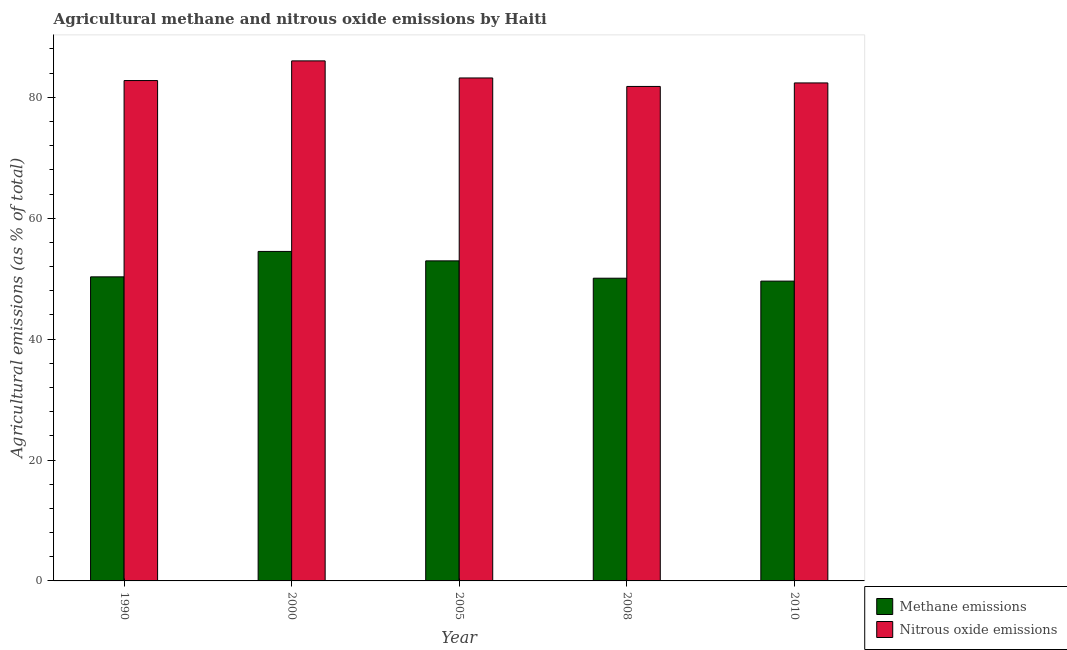Are the number of bars per tick equal to the number of legend labels?
Offer a very short reply. Yes. How many bars are there on the 5th tick from the right?
Make the answer very short. 2. What is the label of the 1st group of bars from the left?
Give a very brief answer. 1990. In how many cases, is the number of bars for a given year not equal to the number of legend labels?
Your answer should be very brief. 0. What is the amount of methane emissions in 2005?
Ensure brevity in your answer.  52.94. Across all years, what is the maximum amount of nitrous oxide emissions?
Provide a short and direct response. 86.03. Across all years, what is the minimum amount of nitrous oxide emissions?
Provide a short and direct response. 81.8. What is the total amount of nitrous oxide emissions in the graph?
Your response must be concise. 416.19. What is the difference between the amount of methane emissions in 2000 and that in 2008?
Make the answer very short. 4.43. What is the difference between the amount of methane emissions in 2005 and the amount of nitrous oxide emissions in 2008?
Your response must be concise. 2.87. What is the average amount of methane emissions per year?
Make the answer very short. 51.49. What is the ratio of the amount of methane emissions in 2008 to that in 2010?
Keep it short and to the point. 1.01. Is the amount of nitrous oxide emissions in 2000 less than that in 2008?
Keep it short and to the point. No. Is the difference between the amount of methane emissions in 1990 and 2000 greater than the difference between the amount of nitrous oxide emissions in 1990 and 2000?
Make the answer very short. No. What is the difference between the highest and the second highest amount of methane emissions?
Your response must be concise. 1.56. What is the difference between the highest and the lowest amount of nitrous oxide emissions?
Make the answer very short. 4.23. In how many years, is the amount of methane emissions greater than the average amount of methane emissions taken over all years?
Your answer should be compact. 2. What does the 1st bar from the left in 1990 represents?
Provide a short and direct response. Methane emissions. What does the 2nd bar from the right in 2005 represents?
Your answer should be compact. Methane emissions. How many years are there in the graph?
Offer a terse response. 5. Are the values on the major ticks of Y-axis written in scientific E-notation?
Your answer should be very brief. No. How many legend labels are there?
Ensure brevity in your answer.  2. What is the title of the graph?
Ensure brevity in your answer.  Agricultural methane and nitrous oxide emissions by Haiti. What is the label or title of the Y-axis?
Your answer should be very brief. Agricultural emissions (as % of total). What is the Agricultural emissions (as % of total) in Methane emissions in 1990?
Your answer should be very brief. 50.3. What is the Agricultural emissions (as % of total) of Nitrous oxide emissions in 1990?
Provide a short and direct response. 82.77. What is the Agricultural emissions (as % of total) of Methane emissions in 2000?
Your answer should be very brief. 54.51. What is the Agricultural emissions (as % of total) in Nitrous oxide emissions in 2000?
Give a very brief answer. 86.03. What is the Agricultural emissions (as % of total) in Methane emissions in 2005?
Make the answer very short. 52.94. What is the Agricultural emissions (as % of total) of Nitrous oxide emissions in 2005?
Your response must be concise. 83.2. What is the Agricultural emissions (as % of total) of Methane emissions in 2008?
Provide a succinct answer. 50.08. What is the Agricultural emissions (as % of total) in Nitrous oxide emissions in 2008?
Provide a succinct answer. 81.8. What is the Agricultural emissions (as % of total) of Methane emissions in 2010?
Offer a terse response. 49.6. What is the Agricultural emissions (as % of total) in Nitrous oxide emissions in 2010?
Keep it short and to the point. 82.38. Across all years, what is the maximum Agricultural emissions (as % of total) in Methane emissions?
Your response must be concise. 54.51. Across all years, what is the maximum Agricultural emissions (as % of total) of Nitrous oxide emissions?
Keep it short and to the point. 86.03. Across all years, what is the minimum Agricultural emissions (as % of total) in Methane emissions?
Give a very brief answer. 49.6. Across all years, what is the minimum Agricultural emissions (as % of total) of Nitrous oxide emissions?
Your answer should be compact. 81.8. What is the total Agricultural emissions (as % of total) of Methane emissions in the graph?
Ensure brevity in your answer.  257.43. What is the total Agricultural emissions (as % of total) of Nitrous oxide emissions in the graph?
Provide a succinct answer. 416.19. What is the difference between the Agricultural emissions (as % of total) in Methane emissions in 1990 and that in 2000?
Your answer should be compact. -4.2. What is the difference between the Agricultural emissions (as % of total) in Nitrous oxide emissions in 1990 and that in 2000?
Provide a short and direct response. -3.25. What is the difference between the Agricultural emissions (as % of total) in Methane emissions in 1990 and that in 2005?
Offer a very short reply. -2.64. What is the difference between the Agricultural emissions (as % of total) of Nitrous oxide emissions in 1990 and that in 2005?
Provide a succinct answer. -0.43. What is the difference between the Agricultural emissions (as % of total) in Methane emissions in 1990 and that in 2008?
Provide a succinct answer. 0.23. What is the difference between the Agricultural emissions (as % of total) in Nitrous oxide emissions in 1990 and that in 2008?
Provide a succinct answer. 0.97. What is the difference between the Agricultural emissions (as % of total) of Methane emissions in 1990 and that in 2010?
Provide a short and direct response. 0.71. What is the difference between the Agricultural emissions (as % of total) of Nitrous oxide emissions in 1990 and that in 2010?
Keep it short and to the point. 0.39. What is the difference between the Agricultural emissions (as % of total) in Methane emissions in 2000 and that in 2005?
Offer a very short reply. 1.56. What is the difference between the Agricultural emissions (as % of total) in Nitrous oxide emissions in 2000 and that in 2005?
Ensure brevity in your answer.  2.83. What is the difference between the Agricultural emissions (as % of total) in Methane emissions in 2000 and that in 2008?
Provide a succinct answer. 4.43. What is the difference between the Agricultural emissions (as % of total) of Nitrous oxide emissions in 2000 and that in 2008?
Offer a very short reply. 4.23. What is the difference between the Agricultural emissions (as % of total) in Methane emissions in 2000 and that in 2010?
Provide a succinct answer. 4.91. What is the difference between the Agricultural emissions (as % of total) in Nitrous oxide emissions in 2000 and that in 2010?
Ensure brevity in your answer.  3.65. What is the difference between the Agricultural emissions (as % of total) of Methane emissions in 2005 and that in 2008?
Offer a very short reply. 2.87. What is the difference between the Agricultural emissions (as % of total) of Nitrous oxide emissions in 2005 and that in 2008?
Ensure brevity in your answer.  1.4. What is the difference between the Agricultural emissions (as % of total) of Methane emissions in 2005 and that in 2010?
Ensure brevity in your answer.  3.35. What is the difference between the Agricultural emissions (as % of total) of Nitrous oxide emissions in 2005 and that in 2010?
Provide a succinct answer. 0.82. What is the difference between the Agricultural emissions (as % of total) in Methane emissions in 2008 and that in 2010?
Offer a terse response. 0.48. What is the difference between the Agricultural emissions (as % of total) in Nitrous oxide emissions in 2008 and that in 2010?
Provide a short and direct response. -0.58. What is the difference between the Agricultural emissions (as % of total) of Methane emissions in 1990 and the Agricultural emissions (as % of total) of Nitrous oxide emissions in 2000?
Your answer should be very brief. -35.73. What is the difference between the Agricultural emissions (as % of total) of Methane emissions in 1990 and the Agricultural emissions (as % of total) of Nitrous oxide emissions in 2005?
Give a very brief answer. -32.9. What is the difference between the Agricultural emissions (as % of total) of Methane emissions in 1990 and the Agricultural emissions (as % of total) of Nitrous oxide emissions in 2008?
Provide a succinct answer. -31.5. What is the difference between the Agricultural emissions (as % of total) in Methane emissions in 1990 and the Agricultural emissions (as % of total) in Nitrous oxide emissions in 2010?
Give a very brief answer. -32.08. What is the difference between the Agricultural emissions (as % of total) in Methane emissions in 2000 and the Agricultural emissions (as % of total) in Nitrous oxide emissions in 2005?
Keep it short and to the point. -28.7. What is the difference between the Agricultural emissions (as % of total) of Methane emissions in 2000 and the Agricultural emissions (as % of total) of Nitrous oxide emissions in 2008?
Your answer should be very brief. -27.29. What is the difference between the Agricultural emissions (as % of total) of Methane emissions in 2000 and the Agricultural emissions (as % of total) of Nitrous oxide emissions in 2010?
Your answer should be very brief. -27.88. What is the difference between the Agricultural emissions (as % of total) of Methane emissions in 2005 and the Agricultural emissions (as % of total) of Nitrous oxide emissions in 2008?
Provide a short and direct response. -28.86. What is the difference between the Agricultural emissions (as % of total) in Methane emissions in 2005 and the Agricultural emissions (as % of total) in Nitrous oxide emissions in 2010?
Offer a very short reply. -29.44. What is the difference between the Agricultural emissions (as % of total) in Methane emissions in 2008 and the Agricultural emissions (as % of total) in Nitrous oxide emissions in 2010?
Give a very brief answer. -32.3. What is the average Agricultural emissions (as % of total) in Methane emissions per year?
Make the answer very short. 51.49. What is the average Agricultural emissions (as % of total) in Nitrous oxide emissions per year?
Ensure brevity in your answer.  83.24. In the year 1990, what is the difference between the Agricultural emissions (as % of total) of Methane emissions and Agricultural emissions (as % of total) of Nitrous oxide emissions?
Provide a short and direct response. -32.47. In the year 2000, what is the difference between the Agricultural emissions (as % of total) of Methane emissions and Agricultural emissions (as % of total) of Nitrous oxide emissions?
Provide a short and direct response. -31.52. In the year 2005, what is the difference between the Agricultural emissions (as % of total) in Methane emissions and Agricultural emissions (as % of total) in Nitrous oxide emissions?
Your answer should be very brief. -30.26. In the year 2008, what is the difference between the Agricultural emissions (as % of total) of Methane emissions and Agricultural emissions (as % of total) of Nitrous oxide emissions?
Provide a short and direct response. -31.72. In the year 2010, what is the difference between the Agricultural emissions (as % of total) of Methane emissions and Agricultural emissions (as % of total) of Nitrous oxide emissions?
Ensure brevity in your answer.  -32.78. What is the ratio of the Agricultural emissions (as % of total) in Methane emissions in 1990 to that in 2000?
Offer a terse response. 0.92. What is the ratio of the Agricultural emissions (as % of total) in Nitrous oxide emissions in 1990 to that in 2000?
Give a very brief answer. 0.96. What is the ratio of the Agricultural emissions (as % of total) of Methane emissions in 1990 to that in 2005?
Make the answer very short. 0.95. What is the ratio of the Agricultural emissions (as % of total) in Nitrous oxide emissions in 1990 to that in 2005?
Give a very brief answer. 0.99. What is the ratio of the Agricultural emissions (as % of total) in Nitrous oxide emissions in 1990 to that in 2008?
Ensure brevity in your answer.  1.01. What is the ratio of the Agricultural emissions (as % of total) in Methane emissions in 1990 to that in 2010?
Provide a succinct answer. 1.01. What is the ratio of the Agricultural emissions (as % of total) of Methane emissions in 2000 to that in 2005?
Make the answer very short. 1.03. What is the ratio of the Agricultural emissions (as % of total) in Nitrous oxide emissions in 2000 to that in 2005?
Your response must be concise. 1.03. What is the ratio of the Agricultural emissions (as % of total) in Methane emissions in 2000 to that in 2008?
Ensure brevity in your answer.  1.09. What is the ratio of the Agricultural emissions (as % of total) of Nitrous oxide emissions in 2000 to that in 2008?
Provide a succinct answer. 1.05. What is the ratio of the Agricultural emissions (as % of total) in Methane emissions in 2000 to that in 2010?
Offer a very short reply. 1.1. What is the ratio of the Agricultural emissions (as % of total) in Nitrous oxide emissions in 2000 to that in 2010?
Offer a terse response. 1.04. What is the ratio of the Agricultural emissions (as % of total) of Methane emissions in 2005 to that in 2008?
Provide a succinct answer. 1.06. What is the ratio of the Agricultural emissions (as % of total) of Nitrous oxide emissions in 2005 to that in 2008?
Give a very brief answer. 1.02. What is the ratio of the Agricultural emissions (as % of total) in Methane emissions in 2005 to that in 2010?
Make the answer very short. 1.07. What is the ratio of the Agricultural emissions (as % of total) of Nitrous oxide emissions in 2005 to that in 2010?
Keep it short and to the point. 1.01. What is the ratio of the Agricultural emissions (as % of total) in Methane emissions in 2008 to that in 2010?
Your answer should be compact. 1.01. What is the difference between the highest and the second highest Agricultural emissions (as % of total) of Methane emissions?
Offer a very short reply. 1.56. What is the difference between the highest and the second highest Agricultural emissions (as % of total) of Nitrous oxide emissions?
Your answer should be compact. 2.83. What is the difference between the highest and the lowest Agricultural emissions (as % of total) of Methane emissions?
Keep it short and to the point. 4.91. What is the difference between the highest and the lowest Agricultural emissions (as % of total) of Nitrous oxide emissions?
Your answer should be very brief. 4.23. 